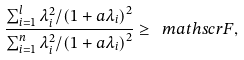<formula> <loc_0><loc_0><loc_500><loc_500>\frac { \sum _ { i = 1 } ^ { l } \lambda _ { i } ^ { 2 } / \left ( 1 + a \lambda _ { i } \right ) ^ { 2 } } { \sum _ { i = 1 } ^ { n } \lambda _ { i } ^ { 2 } / \left ( 1 + a \lambda _ { i } \right ) ^ { 2 } } \geq \ m a t h s c r { F } ,</formula> 